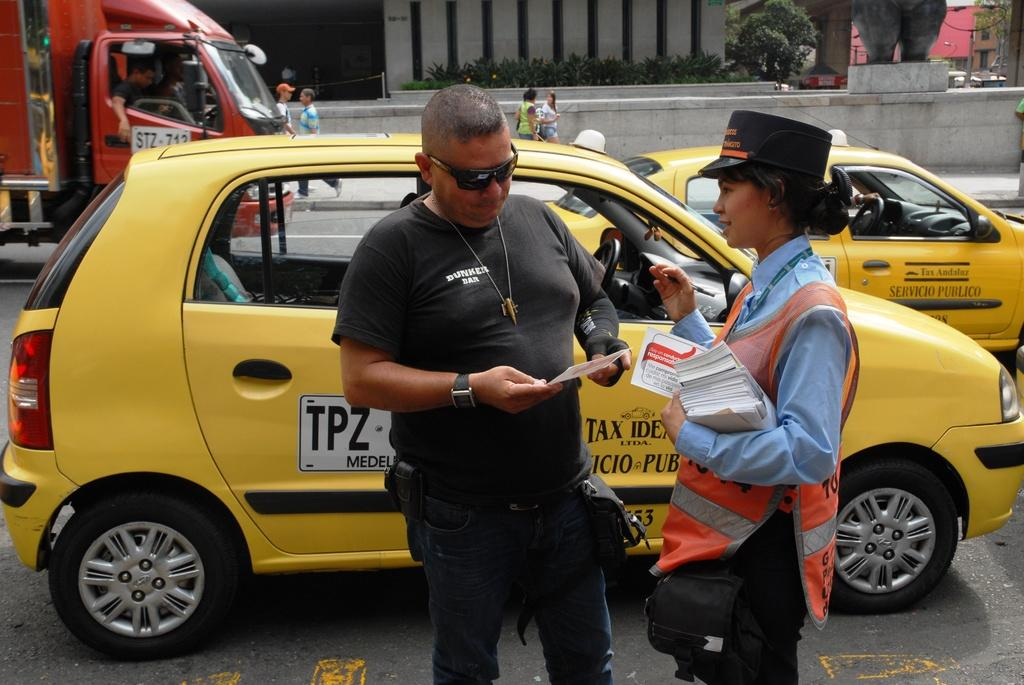<image>
Relay a brief, clear account of the picture shown. a yellow car with TPZ written on the side and two people next to it 